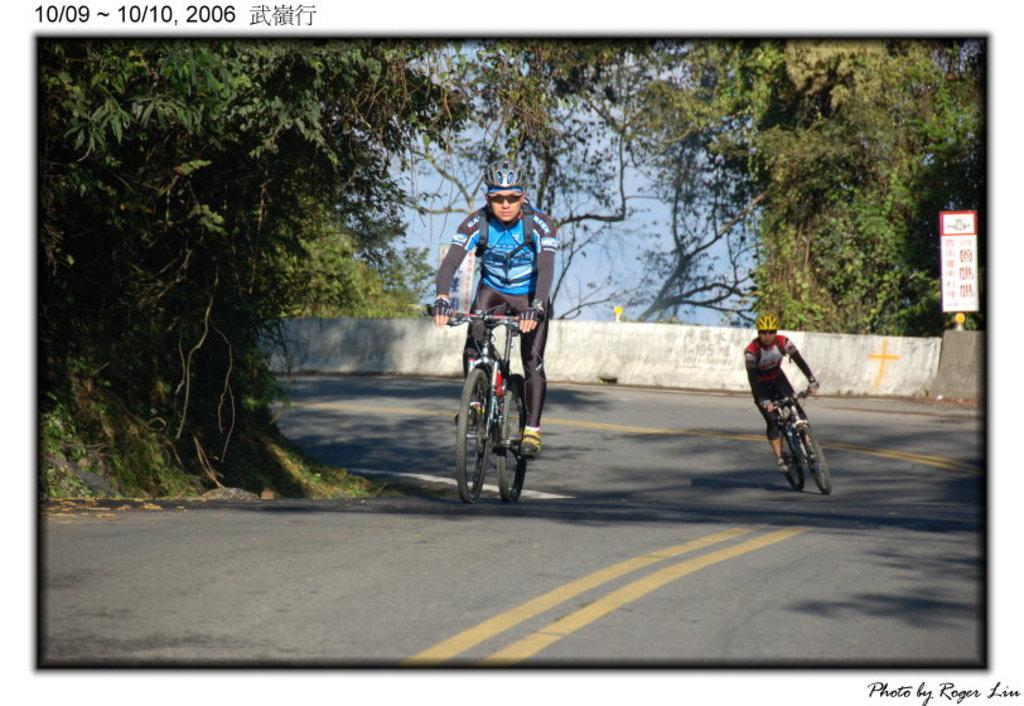What is the main subject of the image? There is a man in the image. What is the man doing in the image? The man is riding a bicycle. Where is the bicycle located in the image? The bicycle is on the road. What can be seen in the background of the image? There is a tree and the sky visible in the image. What architectural feature is present on the road in the image? There is a fence on the road in the image. What arithmetic problem is the man solving while riding the bicycle in the image? There is no indication in the image that the man is solving an arithmetic problem while riding the bicycle. What type of guitar is the man playing while riding the bicycle in the image? There is no guitar present in the image, and the man is not playing any instrument while riding the bicycle. 